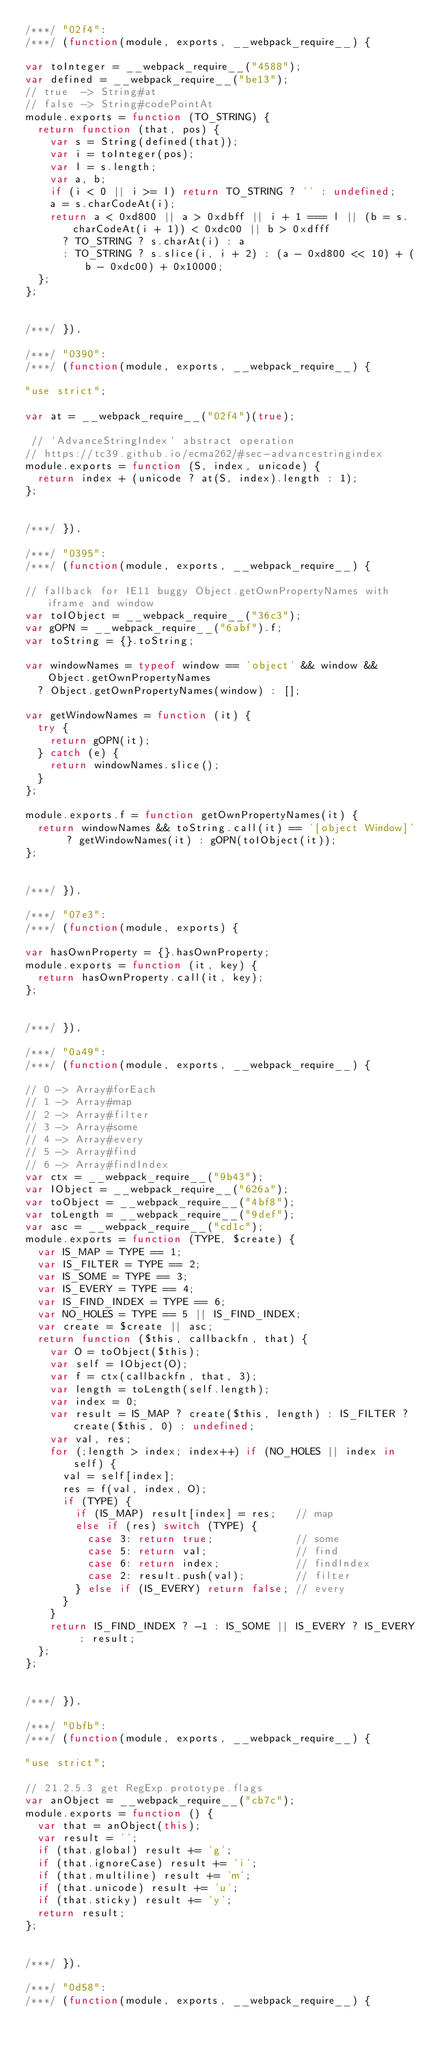Convert code to text. <code><loc_0><loc_0><loc_500><loc_500><_JavaScript_>/***/ "02f4":
/***/ (function(module, exports, __webpack_require__) {

var toInteger = __webpack_require__("4588");
var defined = __webpack_require__("be13");
// true  -> String#at
// false -> String#codePointAt
module.exports = function (TO_STRING) {
  return function (that, pos) {
    var s = String(defined(that));
    var i = toInteger(pos);
    var l = s.length;
    var a, b;
    if (i < 0 || i >= l) return TO_STRING ? '' : undefined;
    a = s.charCodeAt(i);
    return a < 0xd800 || a > 0xdbff || i + 1 === l || (b = s.charCodeAt(i + 1)) < 0xdc00 || b > 0xdfff
      ? TO_STRING ? s.charAt(i) : a
      : TO_STRING ? s.slice(i, i + 2) : (a - 0xd800 << 10) + (b - 0xdc00) + 0x10000;
  };
};


/***/ }),

/***/ "0390":
/***/ (function(module, exports, __webpack_require__) {

"use strict";

var at = __webpack_require__("02f4")(true);

 // `AdvanceStringIndex` abstract operation
// https://tc39.github.io/ecma262/#sec-advancestringindex
module.exports = function (S, index, unicode) {
  return index + (unicode ? at(S, index).length : 1);
};


/***/ }),

/***/ "0395":
/***/ (function(module, exports, __webpack_require__) {

// fallback for IE11 buggy Object.getOwnPropertyNames with iframe and window
var toIObject = __webpack_require__("36c3");
var gOPN = __webpack_require__("6abf").f;
var toString = {}.toString;

var windowNames = typeof window == 'object' && window && Object.getOwnPropertyNames
  ? Object.getOwnPropertyNames(window) : [];

var getWindowNames = function (it) {
  try {
    return gOPN(it);
  } catch (e) {
    return windowNames.slice();
  }
};

module.exports.f = function getOwnPropertyNames(it) {
  return windowNames && toString.call(it) == '[object Window]' ? getWindowNames(it) : gOPN(toIObject(it));
};


/***/ }),

/***/ "07e3":
/***/ (function(module, exports) {

var hasOwnProperty = {}.hasOwnProperty;
module.exports = function (it, key) {
  return hasOwnProperty.call(it, key);
};


/***/ }),

/***/ "0a49":
/***/ (function(module, exports, __webpack_require__) {

// 0 -> Array#forEach
// 1 -> Array#map
// 2 -> Array#filter
// 3 -> Array#some
// 4 -> Array#every
// 5 -> Array#find
// 6 -> Array#findIndex
var ctx = __webpack_require__("9b43");
var IObject = __webpack_require__("626a");
var toObject = __webpack_require__("4bf8");
var toLength = __webpack_require__("9def");
var asc = __webpack_require__("cd1c");
module.exports = function (TYPE, $create) {
  var IS_MAP = TYPE == 1;
  var IS_FILTER = TYPE == 2;
  var IS_SOME = TYPE == 3;
  var IS_EVERY = TYPE == 4;
  var IS_FIND_INDEX = TYPE == 6;
  var NO_HOLES = TYPE == 5 || IS_FIND_INDEX;
  var create = $create || asc;
  return function ($this, callbackfn, that) {
    var O = toObject($this);
    var self = IObject(O);
    var f = ctx(callbackfn, that, 3);
    var length = toLength(self.length);
    var index = 0;
    var result = IS_MAP ? create($this, length) : IS_FILTER ? create($this, 0) : undefined;
    var val, res;
    for (;length > index; index++) if (NO_HOLES || index in self) {
      val = self[index];
      res = f(val, index, O);
      if (TYPE) {
        if (IS_MAP) result[index] = res;   // map
        else if (res) switch (TYPE) {
          case 3: return true;             // some
          case 5: return val;              // find
          case 6: return index;            // findIndex
          case 2: result.push(val);        // filter
        } else if (IS_EVERY) return false; // every
      }
    }
    return IS_FIND_INDEX ? -1 : IS_SOME || IS_EVERY ? IS_EVERY : result;
  };
};


/***/ }),

/***/ "0bfb":
/***/ (function(module, exports, __webpack_require__) {

"use strict";

// 21.2.5.3 get RegExp.prototype.flags
var anObject = __webpack_require__("cb7c");
module.exports = function () {
  var that = anObject(this);
  var result = '';
  if (that.global) result += 'g';
  if (that.ignoreCase) result += 'i';
  if (that.multiline) result += 'm';
  if (that.unicode) result += 'u';
  if (that.sticky) result += 'y';
  return result;
};


/***/ }),

/***/ "0d58":
/***/ (function(module, exports, __webpack_require__) {
</code> 